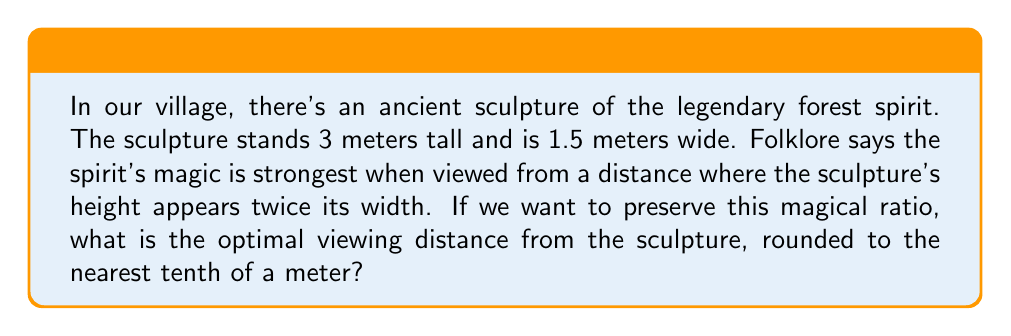What is the answer to this math problem? Let's approach this step-by-step:

1) First, we need to understand the concept of similar triangles. The viewer's eyes, the top of the sculpture, and the bottom of the sculpture form a triangle similar to the one formed by the viewer's eyes and the width of the sculpture.

2) Let's define our variables:
   $h$ = height of sculpture = 3 m
   $w$ = width of sculpture = 1.5 m
   $d$ = optimal viewing distance (what we're solving for)

3) According to the folklore, the optimal view is when the height appears twice the width. We can express this as a ratio:

   $$\frac{\text{apparent height}}{\text{apparent width}} = 2$$

4) Using similar triangles, we can set up the following equation:

   $$\frac{h}{w} = \frac{h/d}{w/d} = 2$$

5) Simplify:

   $$\frac{3}{1.5} = \frac{3/d}{1.5/d} = 2$$

6) The left side simplifies to 2, confirming our ratio. Now we can solve for $d$:

   $$\frac{3/d}{1.5/d} = 2$$

7) Simplify:

   $$\frac{3}{1.5} = 2$$

8) This equation is always true, regardless of $d$. This means any distance will maintain the 2:1 ratio. However, we need to find the specific distance where the apparent height is exactly twice the apparent width.

9) We can use the tangent function to find this:

   $$\tan(\theta) = \frac{h}{d} = \frac{w}{d/2}$$

10) Substitute known values:

    $$\frac{3}{d} = \frac{1.5}{d/2}$$

11) Simplify:

    $$\frac{6}{d} = \frac{3}{d}$$

12) Solve for $d$:

    $$d = 6 \text{ meters}$$

13) Rounding to the nearest tenth:

    $$d \approx 6.0 \text{ meters}$$
Answer: 6.0 meters 